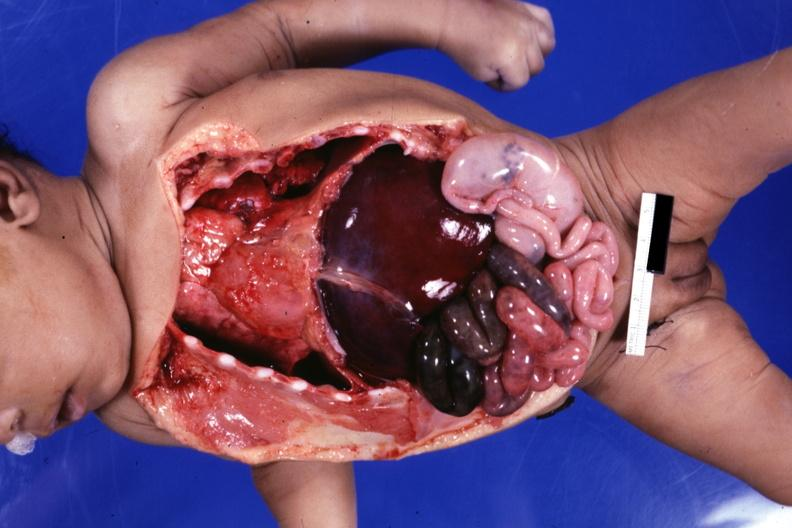what opened showing cardiac apex to right, right liver lobe on left cecum on left gangrenous small bowel?
Answer the question using a single word or phrase. Infant body 